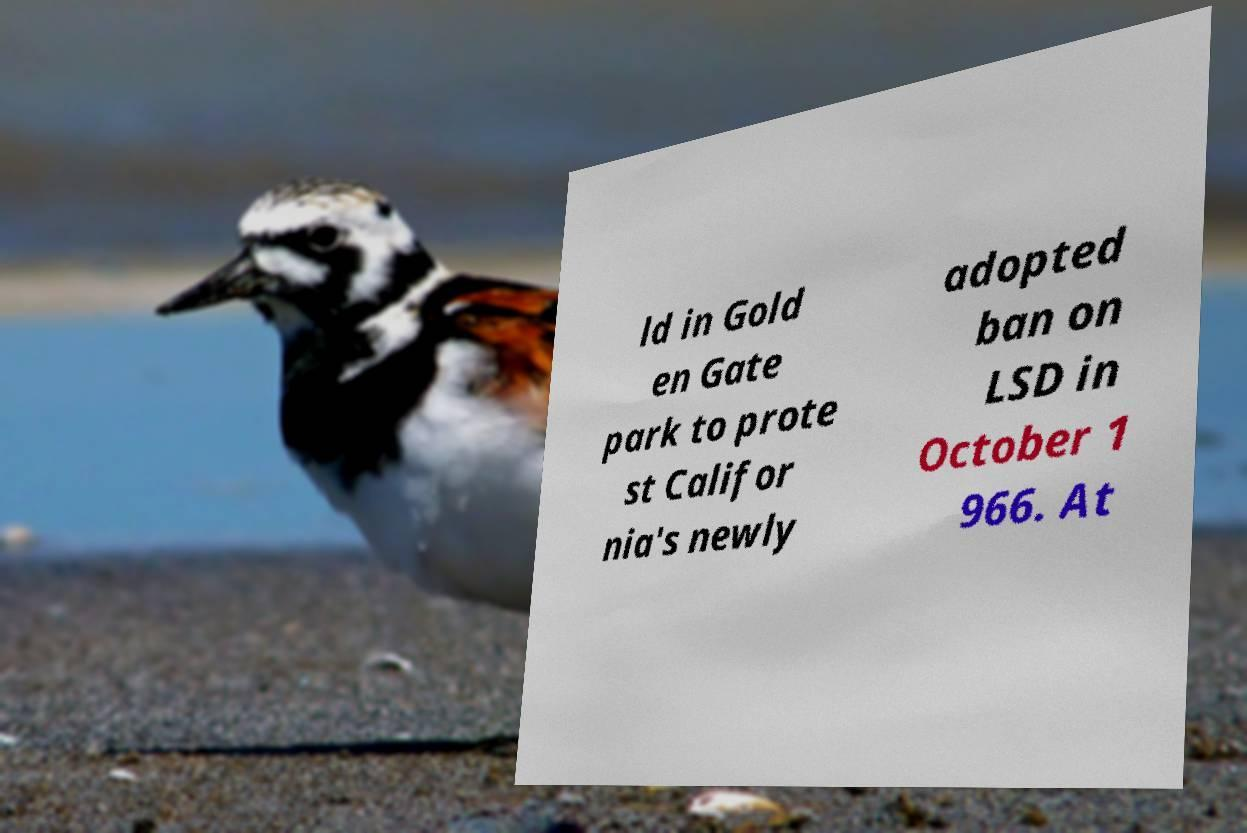Can you accurately transcribe the text from the provided image for me? ld in Gold en Gate park to prote st Califor nia's newly adopted ban on LSD in October 1 966. At 